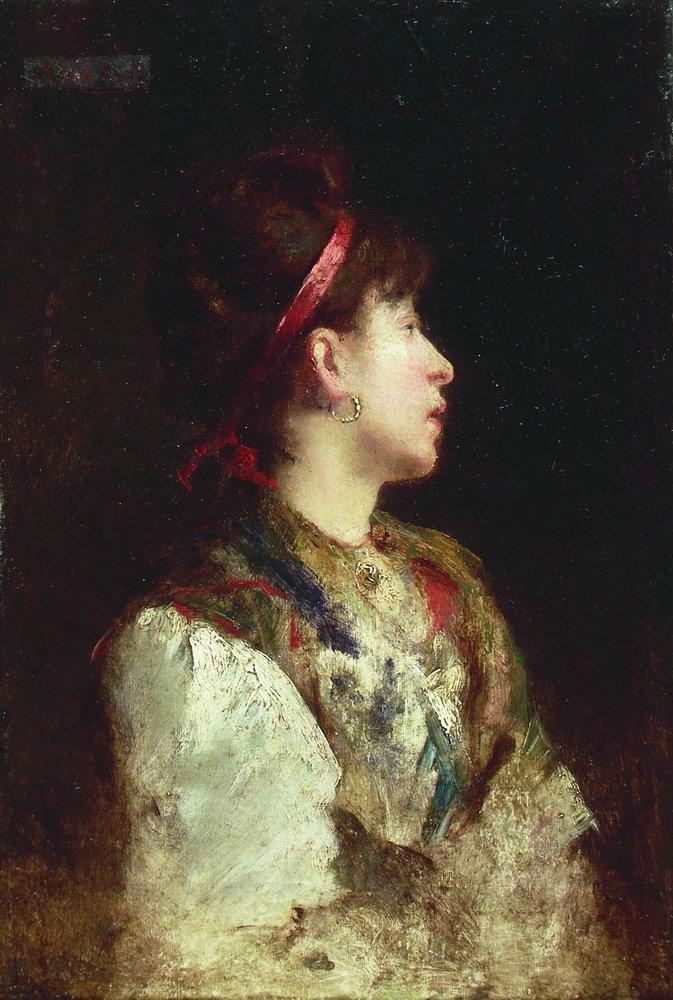Analyze the art techniques used in the portrait. The portrait employs a classic impressionist technique, characterized by loose brushstrokes and a focus on light and its changing qualities. The artist skillfully balances color and shadow to create depth and dimension. The use of a dark, undefined background contrasts with the illuminated figure, drawing attention to the young woman’s profile. The red headband and colorful shawl are rendered with dynamic strokes, enhancing the subject's vibrancy against the muted tones of her blouse and darker hues of the backdrop. This approach not only captures the physical form but also imparts an emotional and psychological depth to the portrait. 